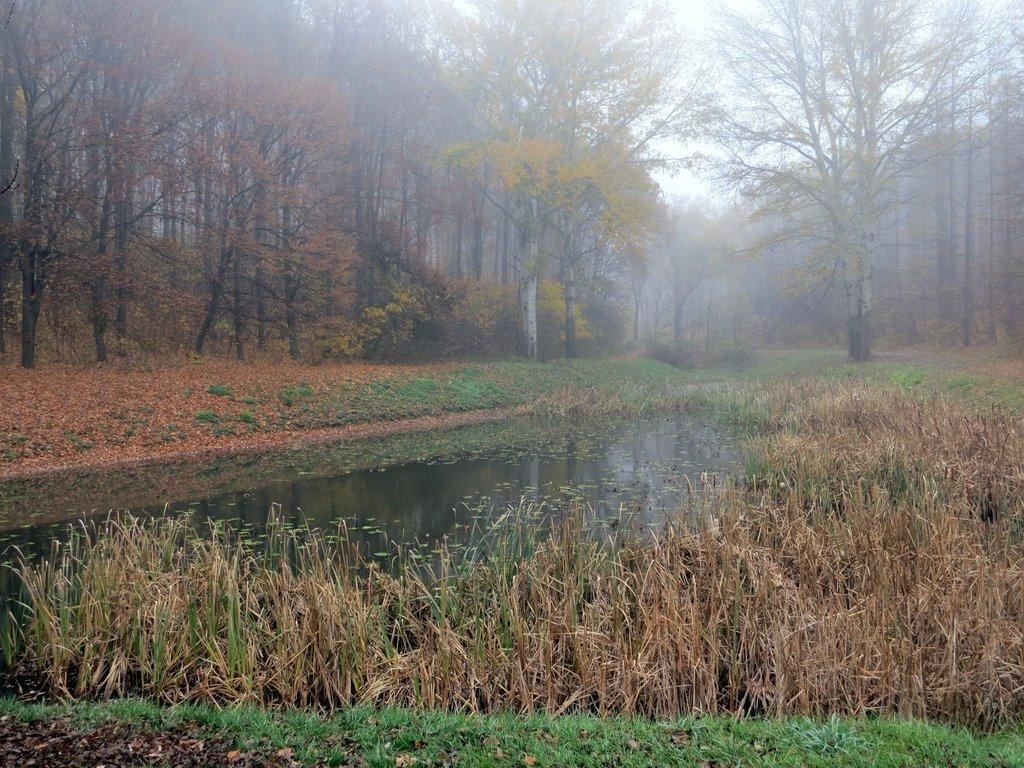In one or two sentences, can you explain what this image depicts? As we can see in the image there is grass, water, plants, trees and sky. 